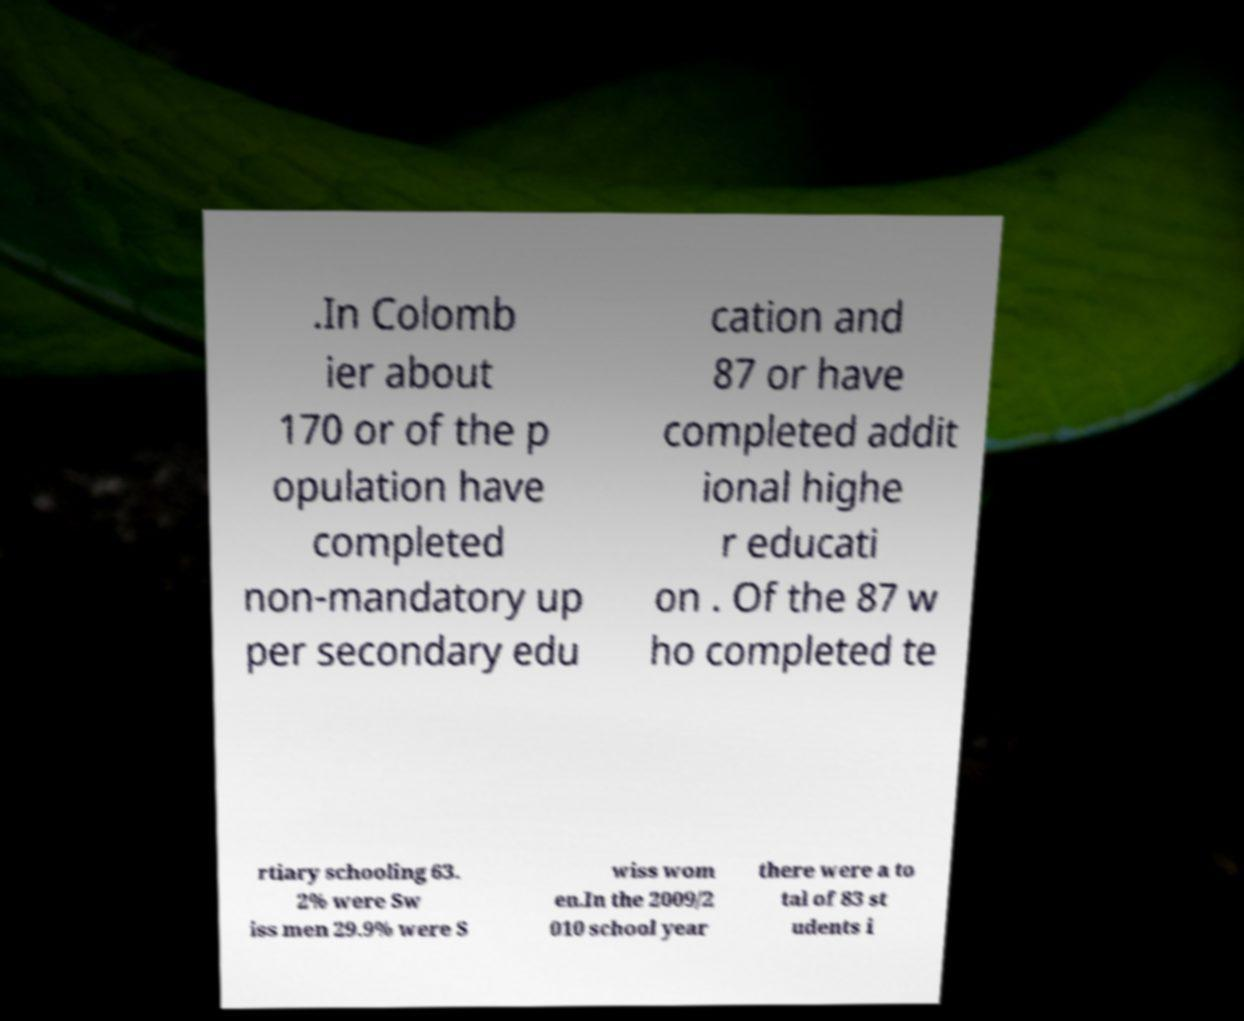Could you extract and type out the text from this image? .In Colomb ier about 170 or of the p opulation have completed non-mandatory up per secondary edu cation and 87 or have completed addit ional highe r educati on . Of the 87 w ho completed te rtiary schooling 63. 2% were Sw iss men 29.9% were S wiss wom en.In the 2009/2 010 school year there were a to tal of 83 st udents i 